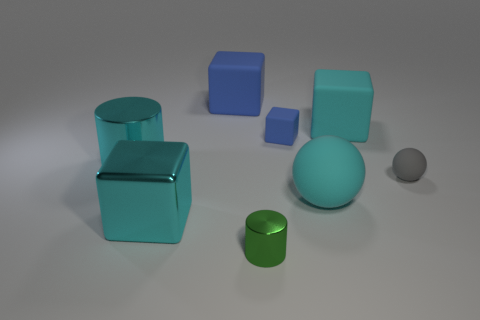Subtract all small rubber cubes. How many cubes are left? 3 Subtract all cylinders. How many objects are left? 6 Subtract all blue blocks. How many blocks are left? 2 Add 2 tiny purple things. How many objects exist? 10 Subtract all cyan blocks. How many green cylinders are left? 1 Subtract all small green things. Subtract all tiny green metallic cylinders. How many objects are left? 6 Add 7 large cyan matte cubes. How many large cyan matte cubes are left? 8 Add 4 tiny yellow metallic cubes. How many tiny yellow metallic cubes exist? 4 Subtract 2 cyan cubes. How many objects are left? 6 Subtract 1 balls. How many balls are left? 1 